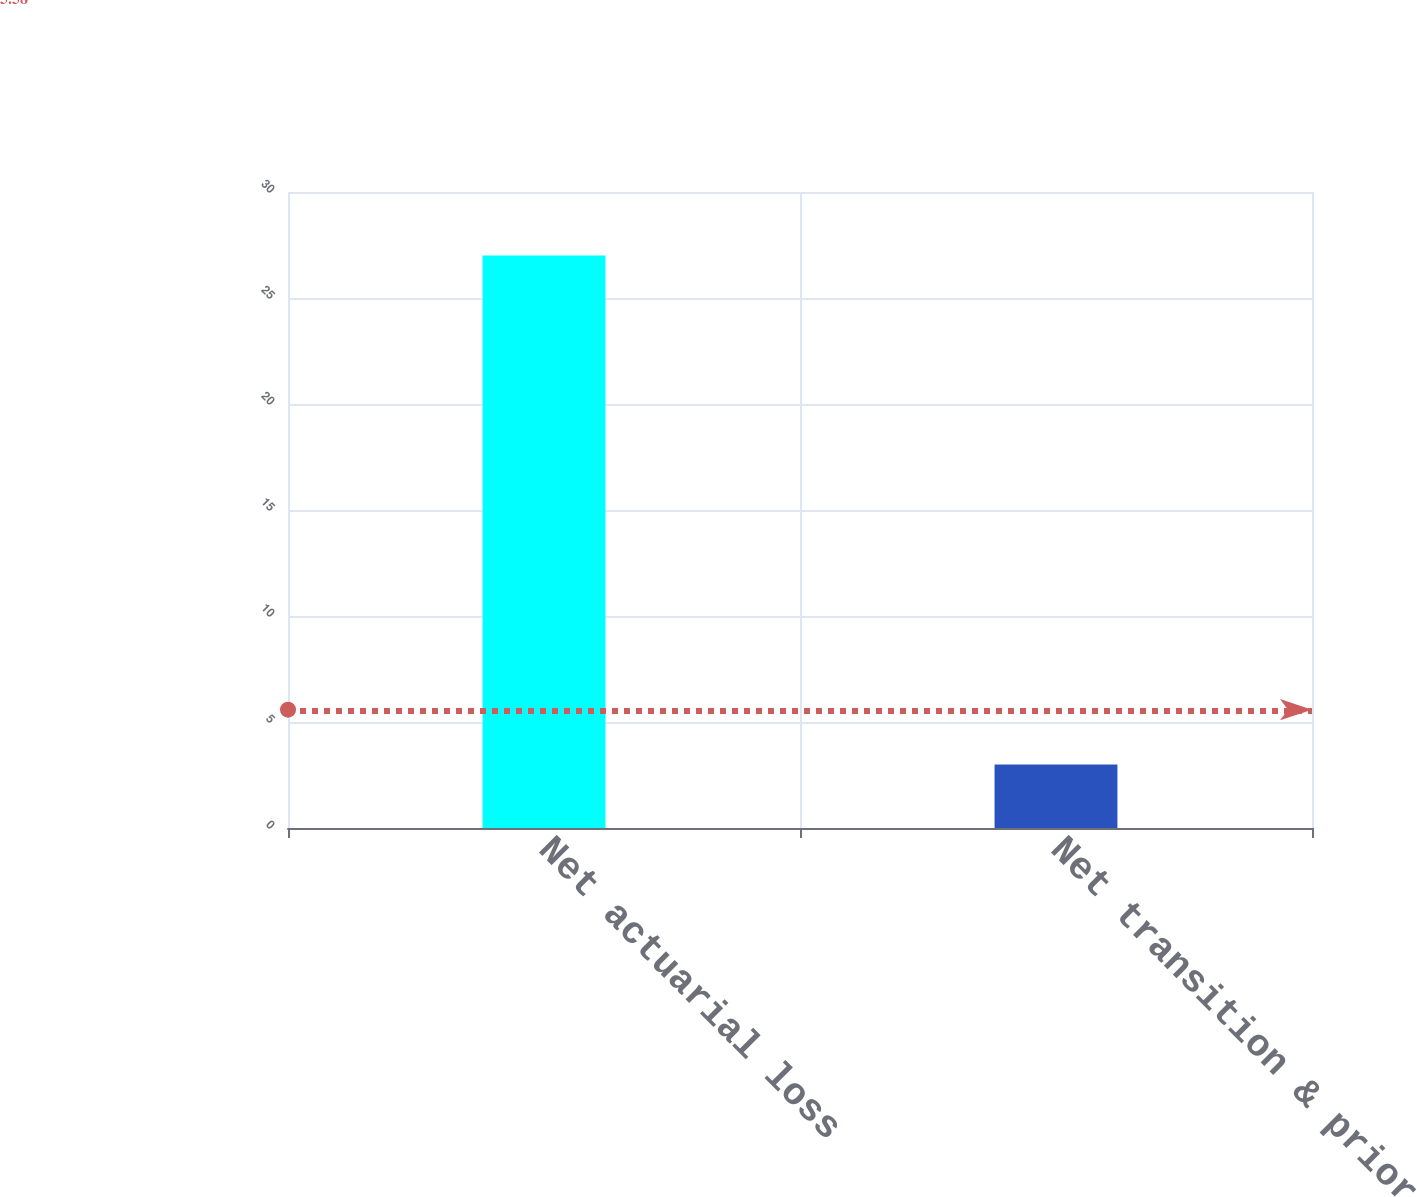Convert chart. <chart><loc_0><loc_0><loc_500><loc_500><bar_chart><fcel>Net actuarial loss<fcel>Net transition & prior service<nl><fcel>27<fcel>3<nl></chart> 